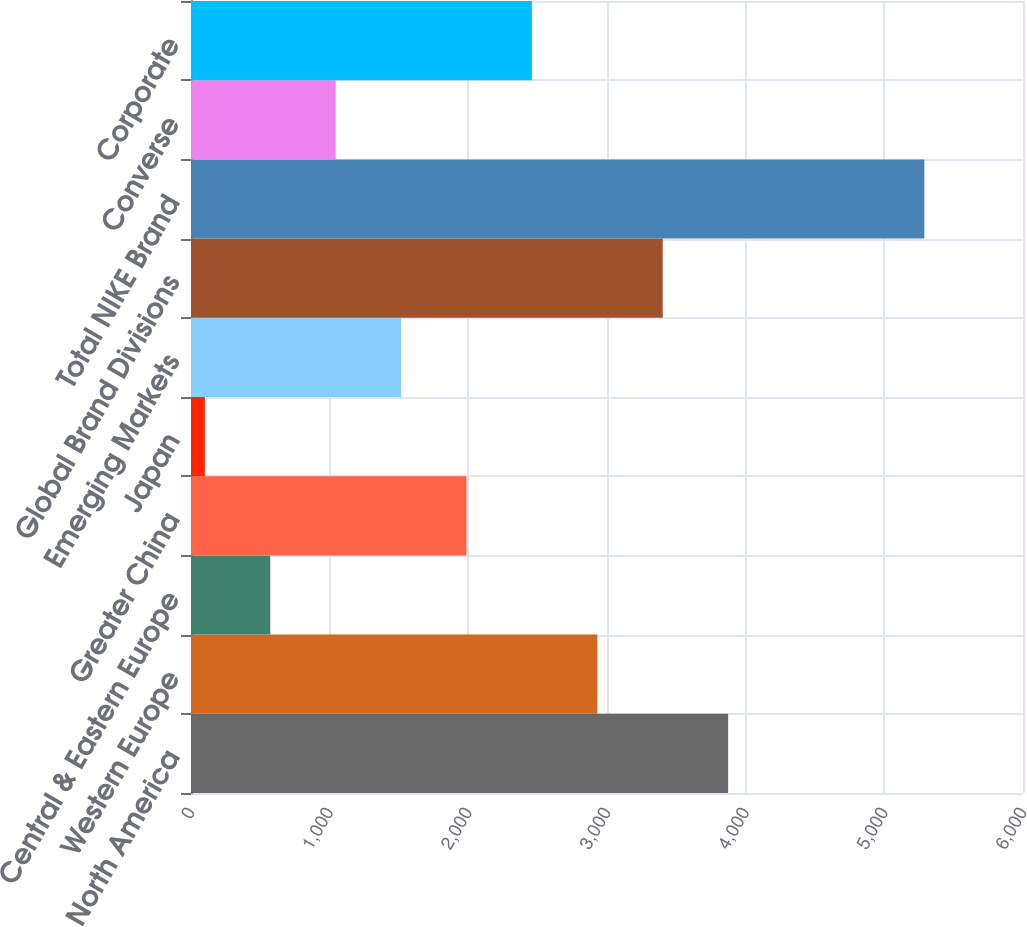<chart> <loc_0><loc_0><loc_500><loc_500><bar_chart><fcel>North America<fcel>Western Europe<fcel>Central & Eastern Europe<fcel>Greater China<fcel>Japan<fcel>Emerging Markets<fcel>Global Brand Divisions<fcel>Total NIKE Brand<fcel>Converse<fcel>Corporate<nl><fcel>3873.6<fcel>2930.2<fcel>571.7<fcel>1986.8<fcel>100<fcel>1515.1<fcel>3401.9<fcel>5288.7<fcel>1043.4<fcel>2458.5<nl></chart> 